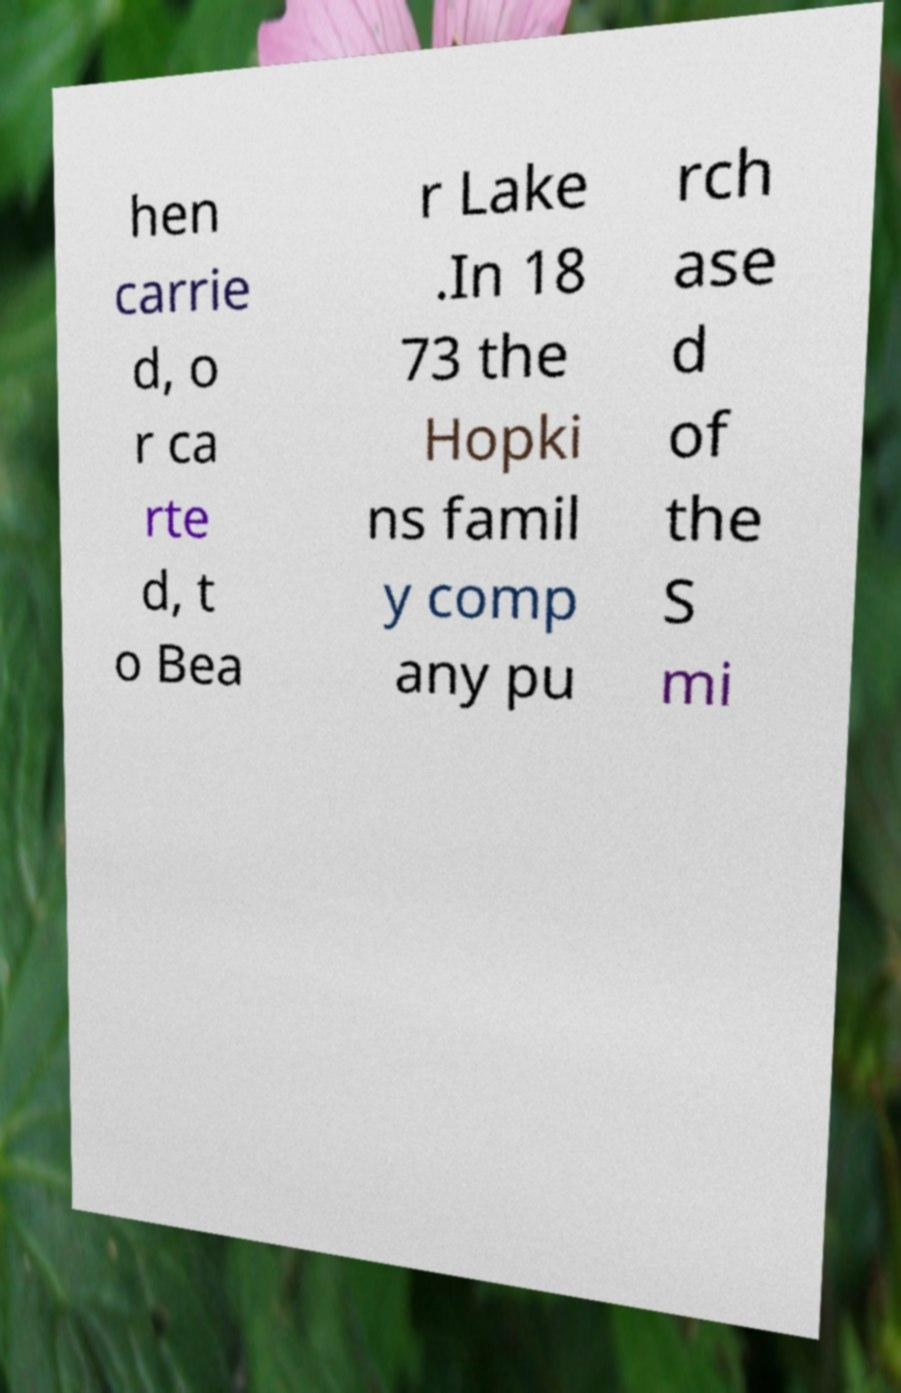Please identify and transcribe the text found in this image. hen carrie d, o r ca rte d, t o Bea r Lake .In 18 73 the Hopki ns famil y comp any pu rch ase d of the S mi 